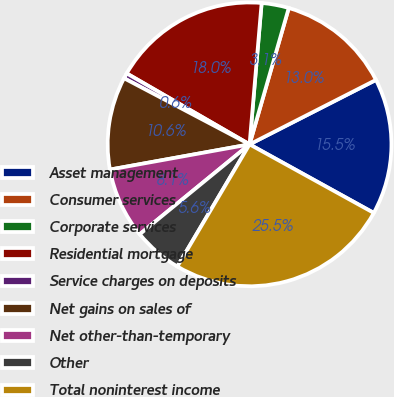Convert chart to OTSL. <chart><loc_0><loc_0><loc_500><loc_500><pie_chart><fcel>Asset management<fcel>Consumer services<fcel>Corporate services<fcel>Residential mortgage<fcel>Service charges on deposits<fcel>Net gains on sales of<fcel>Net other-than-temporary<fcel>Other<fcel>Total noninterest income<nl><fcel>15.53%<fcel>13.04%<fcel>3.1%<fcel>18.02%<fcel>0.62%<fcel>10.56%<fcel>8.07%<fcel>5.59%<fcel>25.47%<nl></chart> 